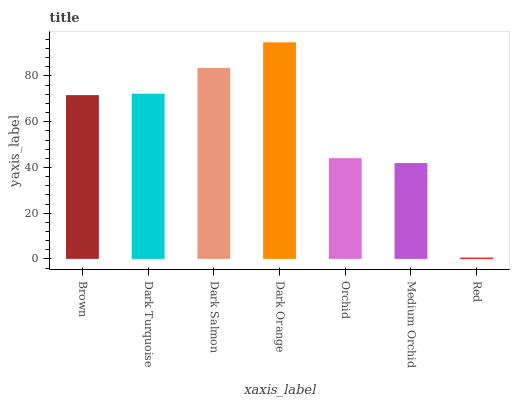Is Red the minimum?
Answer yes or no. Yes. Is Dark Orange the maximum?
Answer yes or no. Yes. Is Dark Turquoise the minimum?
Answer yes or no. No. Is Dark Turquoise the maximum?
Answer yes or no. No. Is Dark Turquoise greater than Brown?
Answer yes or no. Yes. Is Brown less than Dark Turquoise?
Answer yes or no. Yes. Is Brown greater than Dark Turquoise?
Answer yes or no. No. Is Dark Turquoise less than Brown?
Answer yes or no. No. Is Brown the high median?
Answer yes or no. Yes. Is Brown the low median?
Answer yes or no. Yes. Is Dark Turquoise the high median?
Answer yes or no. No. Is Medium Orchid the low median?
Answer yes or no. No. 